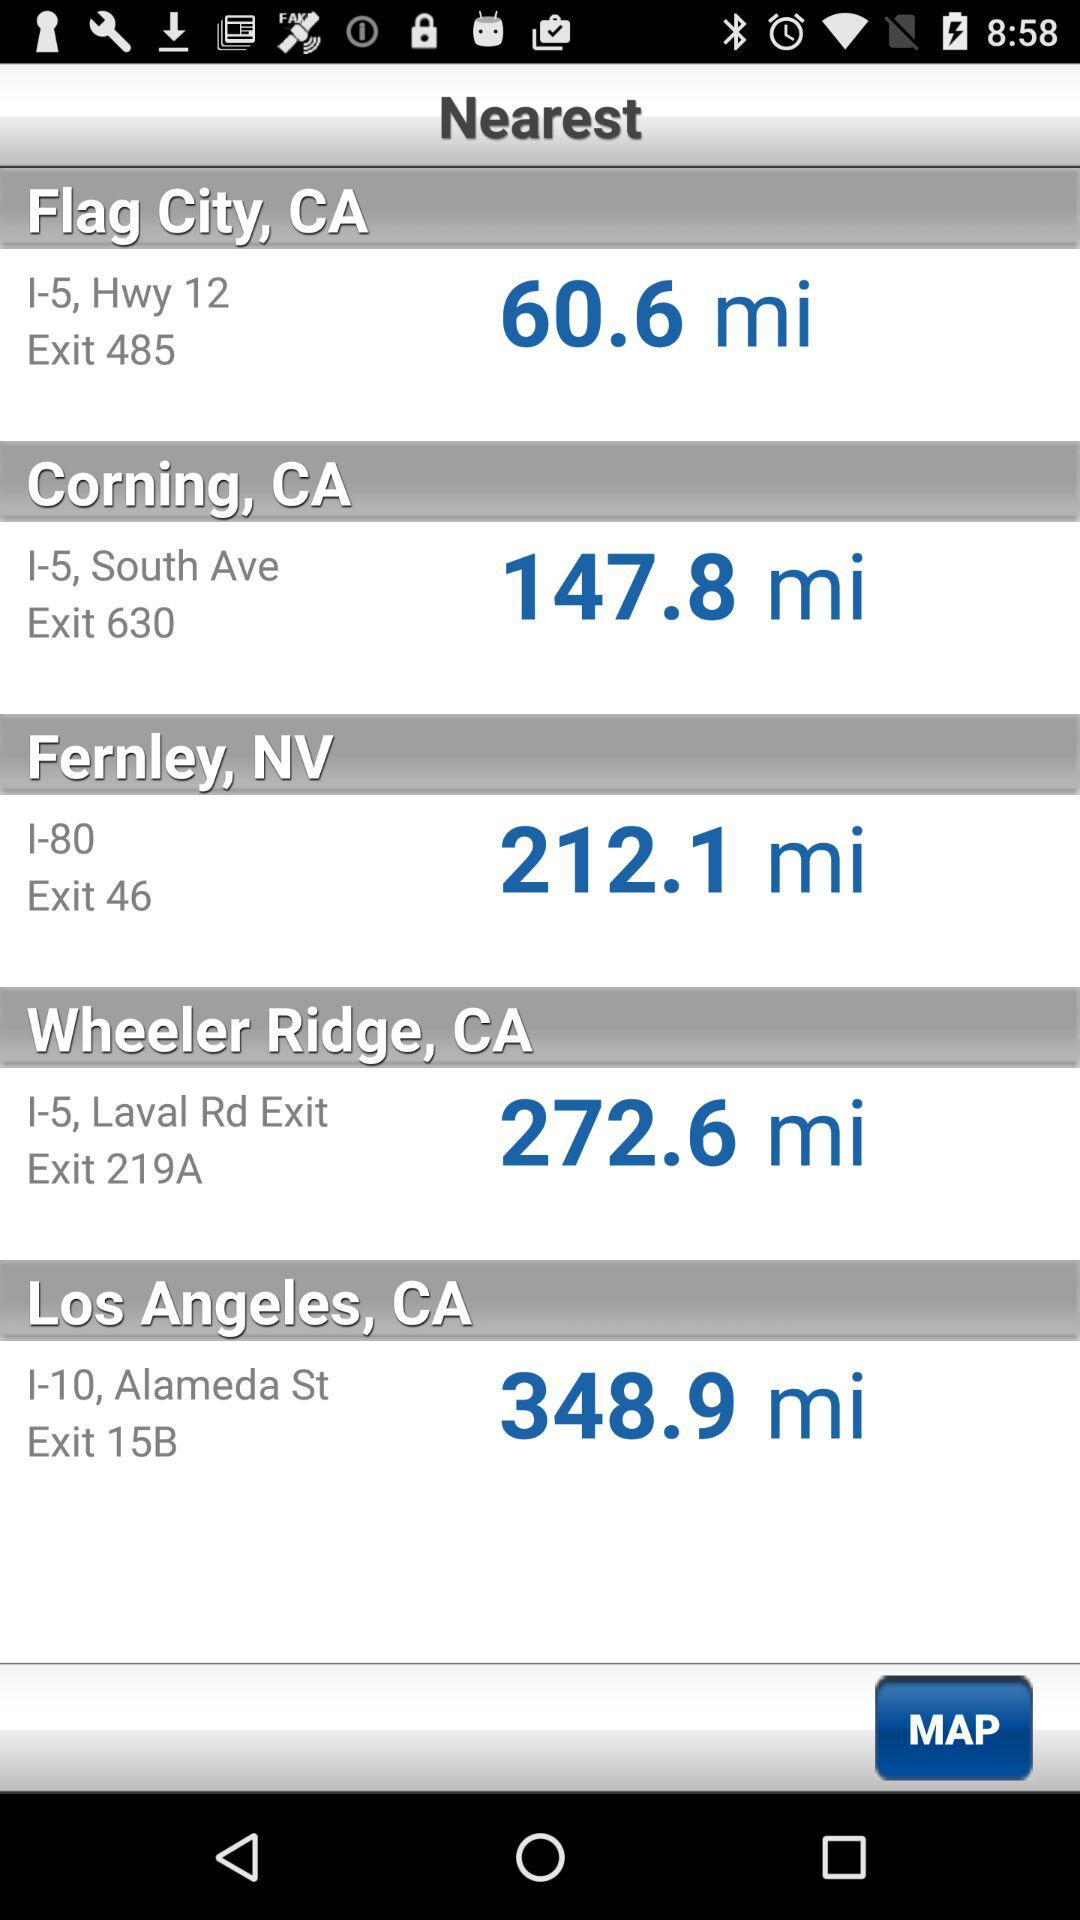What exit is for Fernley City? The exit for Fernley City is 46. 